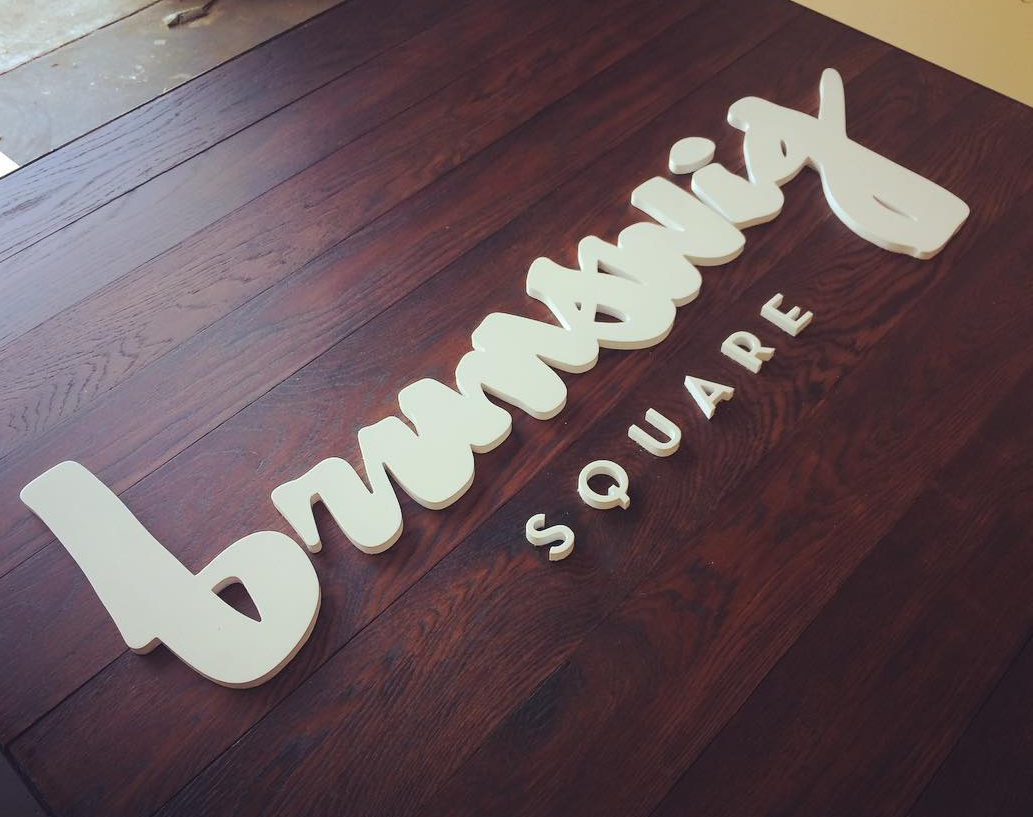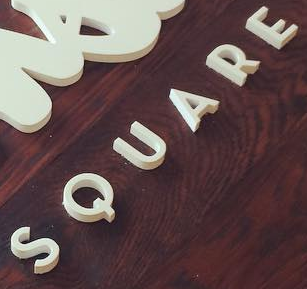What words are shown in these images in order, separated by a semicolon? brunswig; SQUARE 